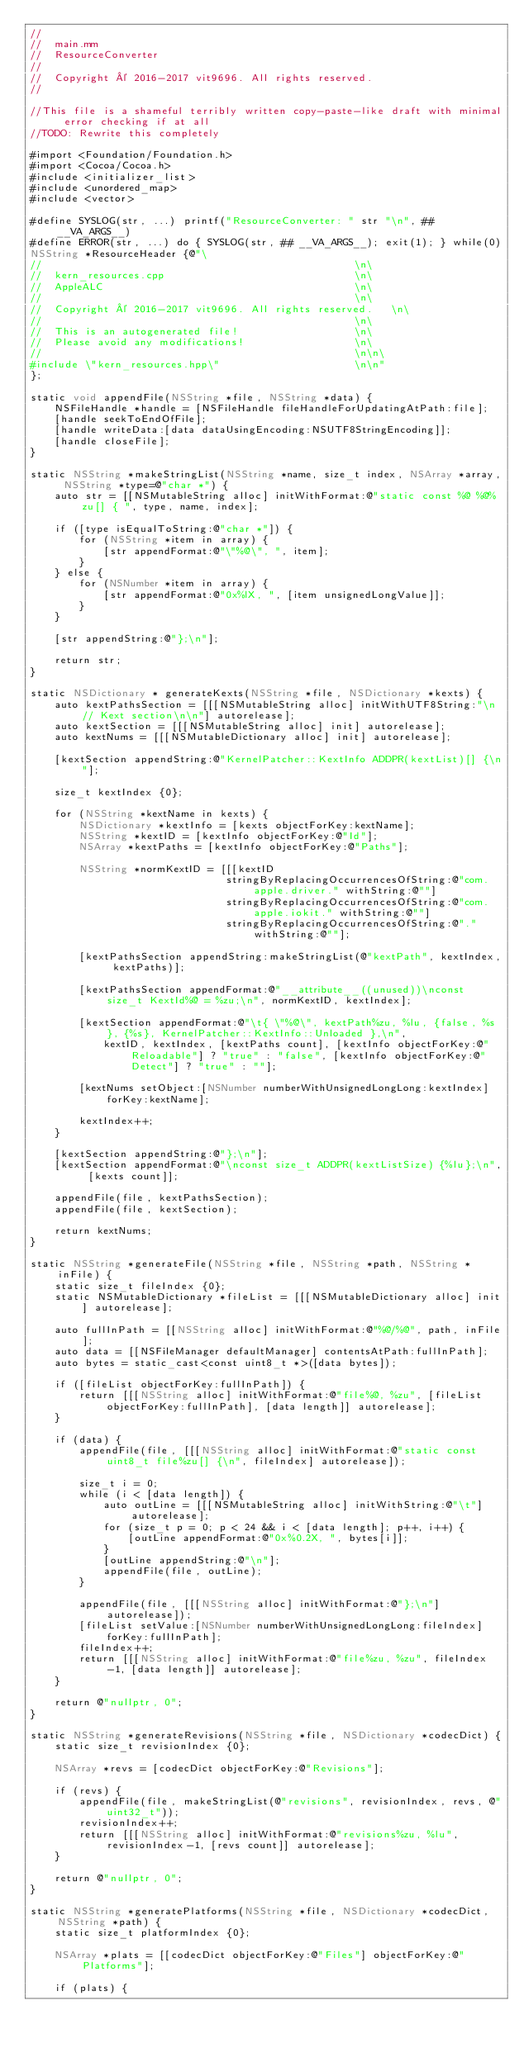Convert code to text. <code><loc_0><loc_0><loc_500><loc_500><_ObjectiveC_>//
//  main.mm
//  ResourceConverter
//
//  Copyright © 2016-2017 vit9696. All rights reserved.
//

//This file is a shameful terribly written copy-paste-like draft with minimal error checking if at all
//TODO: Rewrite this completely

#import <Foundation/Foundation.h>
#import <Cocoa/Cocoa.h>
#include <initializer_list>
#include <unordered_map>
#include <vector>

#define SYSLOG(str, ...) printf("ResourceConverter: " str "\n", ## __VA_ARGS__)
#define ERROR(str, ...) do { SYSLOG(str, ## __VA_ARGS__); exit(1); } while(0)
NSString *ResourceHeader {@"\
//                                                   \n\
//  kern_resources.cpp                               \n\
//  AppleALC                                         \n\
//                                                   \n\
//  Copyright © 2016-2017 vit9696. All rights reserved.   \n\
//                                                   \n\
//  This is an autogenerated file!                   \n\
//  Please avoid any modifications!                  \n\
//                                                   \n\n\
#include \"kern_resources.hpp\"                      \n\n"
};

static void appendFile(NSString *file, NSString *data) {
	NSFileHandle *handle = [NSFileHandle fileHandleForUpdatingAtPath:file];
	[handle seekToEndOfFile];
	[handle writeData:[data dataUsingEncoding:NSUTF8StringEncoding]];
	[handle closeFile];
}

static NSString *makeStringList(NSString *name, size_t index, NSArray *array, NSString *type=@"char *") {
	auto str = [[NSMutableString alloc] initWithFormat:@"static const %@ %@%zu[] { ", type, name, index];
	
	if ([type isEqualToString:@"char *"]) {
		for (NSString *item in array) {
			[str appendFormat:@"\"%@\", ", item];
		}
	} else {
		for (NSNumber *item in array) {
			[str appendFormat:@"0x%lX, ", [item unsignedLongValue]];
		}
	}
	
	[str appendString:@"};\n"];
	
	return str;
}

static NSDictionary * generateKexts(NSString *file, NSDictionary *kexts) {
	auto kextPathsSection = [[[NSMutableString alloc] initWithUTF8String:"\n// Kext section\n\n"] autorelease];
	auto kextSection = [[[NSMutableString alloc] init] autorelease];
	auto kextNums = [[[NSMutableDictionary alloc] init] autorelease];
	
	[kextSection appendString:@"KernelPatcher::KextInfo ADDPR(kextList)[] {\n"];
	
	size_t kextIndex {0};
	
	for (NSString *kextName in kexts) {
		NSDictionary *kextInfo = [kexts objectForKey:kextName];
		NSString *kextID = [kextInfo objectForKey:@"Id"];
		NSArray *kextPaths = [kextInfo objectForKey:@"Paths"];

		NSString *normKextID = [[[kextID
								stringByReplacingOccurrencesOfString:@"com.apple.driver." withString:@""]
								stringByReplacingOccurrencesOfString:@"com.apple.iokit." withString:@""]
								stringByReplacingOccurrencesOfString:@"." withString:@""];
		
		[kextPathsSection appendString:makeStringList(@"kextPath", kextIndex, kextPaths)];

		[kextPathsSection appendFormat:@"__attribute__((unused))\nconst size_t KextId%@ = %zu;\n", normKextID, kextIndex];
		
		[kextSection appendFormat:@"\t{ \"%@\", kextPath%zu, %lu, {false, %s}, {%s}, KernelPatcher::KextInfo::Unloaded },\n",
			kextID, kextIndex, [kextPaths count], [kextInfo objectForKey:@"Reloadable"] ? "true" : "false", [kextInfo objectForKey:@"Detect"] ? "true" : ""];
		
		[kextNums setObject:[NSNumber numberWithUnsignedLongLong:kextIndex] forKey:kextName];
		
		kextIndex++;
	}
	
	[kextSection appendString:@"};\n"];
	[kextSection appendFormat:@"\nconst size_t ADDPR(kextListSize) {%lu};\n", [kexts count]];

	appendFile(file, kextPathsSection);
	appendFile(file, kextSection);

	return kextNums;
}

static NSString *generateFile(NSString *file, NSString *path, NSString *inFile) {
	static size_t fileIndex {0};
	static NSMutableDictionary *fileList = [[[NSMutableDictionary alloc] init] autorelease];
	
	auto fullInPath = [[NSString alloc] initWithFormat:@"%@/%@", path, inFile];
	auto data = [[NSFileManager defaultManager] contentsAtPath:fullInPath];
	auto bytes = static_cast<const uint8_t *>([data bytes]);
	
	if ([fileList objectForKey:fullInPath]) {
		return [[[NSString alloc] initWithFormat:@"file%@, %zu", [fileList objectForKey:fullInPath], [data length]] autorelease];
	}
	
	if (data) {
		appendFile(file, [[[NSString alloc] initWithFormat:@"static const uint8_t file%zu[] {\n", fileIndex] autorelease]);
		
		size_t i = 0;
		while (i < [data length]) {
			auto outLine = [[[NSMutableString alloc] initWithString:@"\t"] autorelease];
			for (size_t p = 0; p < 24 && i < [data length]; p++, i++) {
				[outLine appendFormat:@"0x%0.2X, ", bytes[i]];
			}
			[outLine appendString:@"\n"];
			appendFile(file, outLine);
		}
		
		appendFile(file, [[[NSString alloc] initWithFormat:@"};\n"] autorelease]);
		[fileList setValue:[NSNumber numberWithUnsignedLongLong:fileIndex] forKey:fullInPath];
		fileIndex++;
		return [[[NSString alloc] initWithFormat:@"file%zu, %zu", fileIndex-1, [data length]] autorelease];
	}
	
	return @"nullptr, 0";
}

static NSString *generateRevisions(NSString *file, NSDictionary *codecDict) {
	static size_t revisionIndex {0};
	
	NSArray *revs = [codecDict objectForKey:@"Revisions"];
	
	if (revs) {
		appendFile(file, makeStringList(@"revisions", revisionIndex, revs, @"uint32_t"));
		revisionIndex++;
		return [[[NSString alloc] initWithFormat:@"revisions%zu, %lu", revisionIndex-1, [revs count]] autorelease];
	}
	
	return @"nullptr, 0";
}

static NSString *generatePlatforms(NSString *file, NSDictionary *codecDict, NSString *path) {
	static size_t platformIndex {0};
	
	NSArray *plats = [[codecDict objectForKey:@"Files"] objectForKey:@"Platforms"];
	
	if (plats) {</code> 